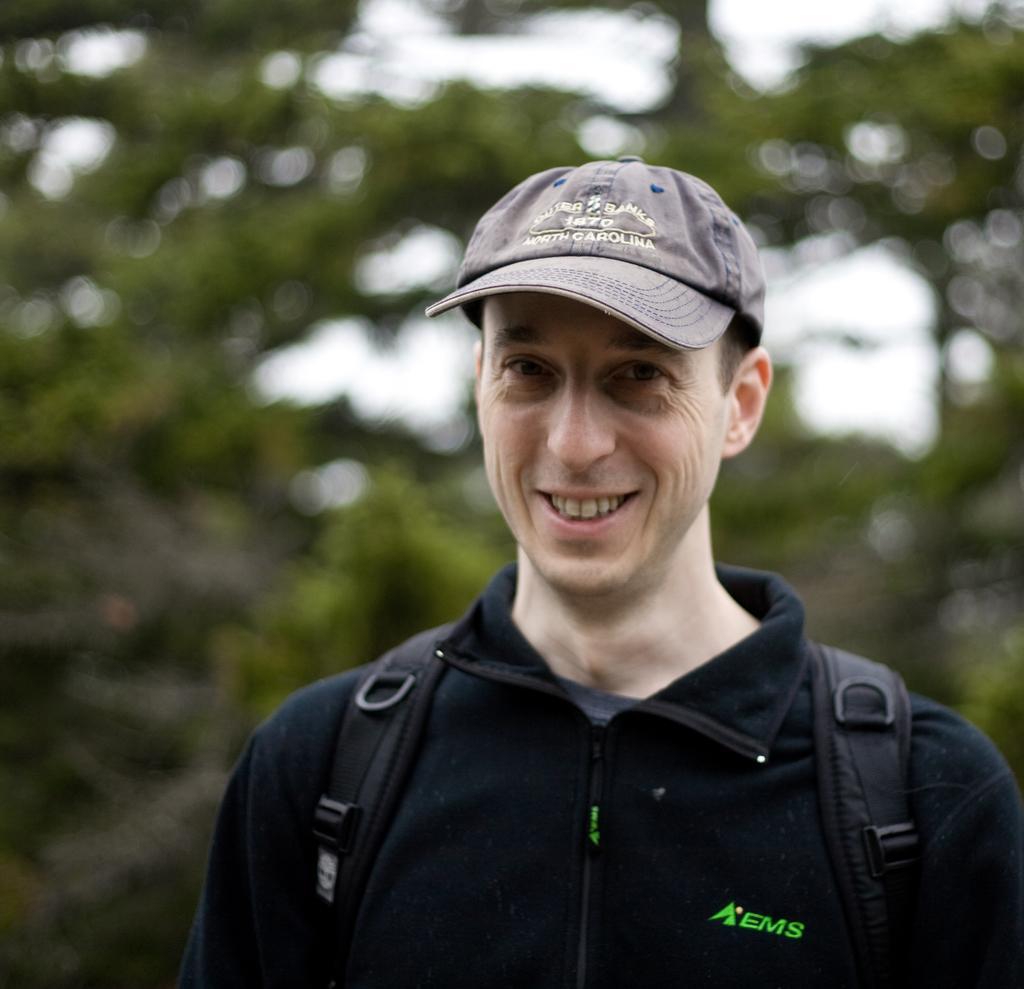In one or two sentences, can you explain what this image depicts? There is a person in black color t-shirt, wearing a bag and cap, smiling and standing. And the background is blurred. 